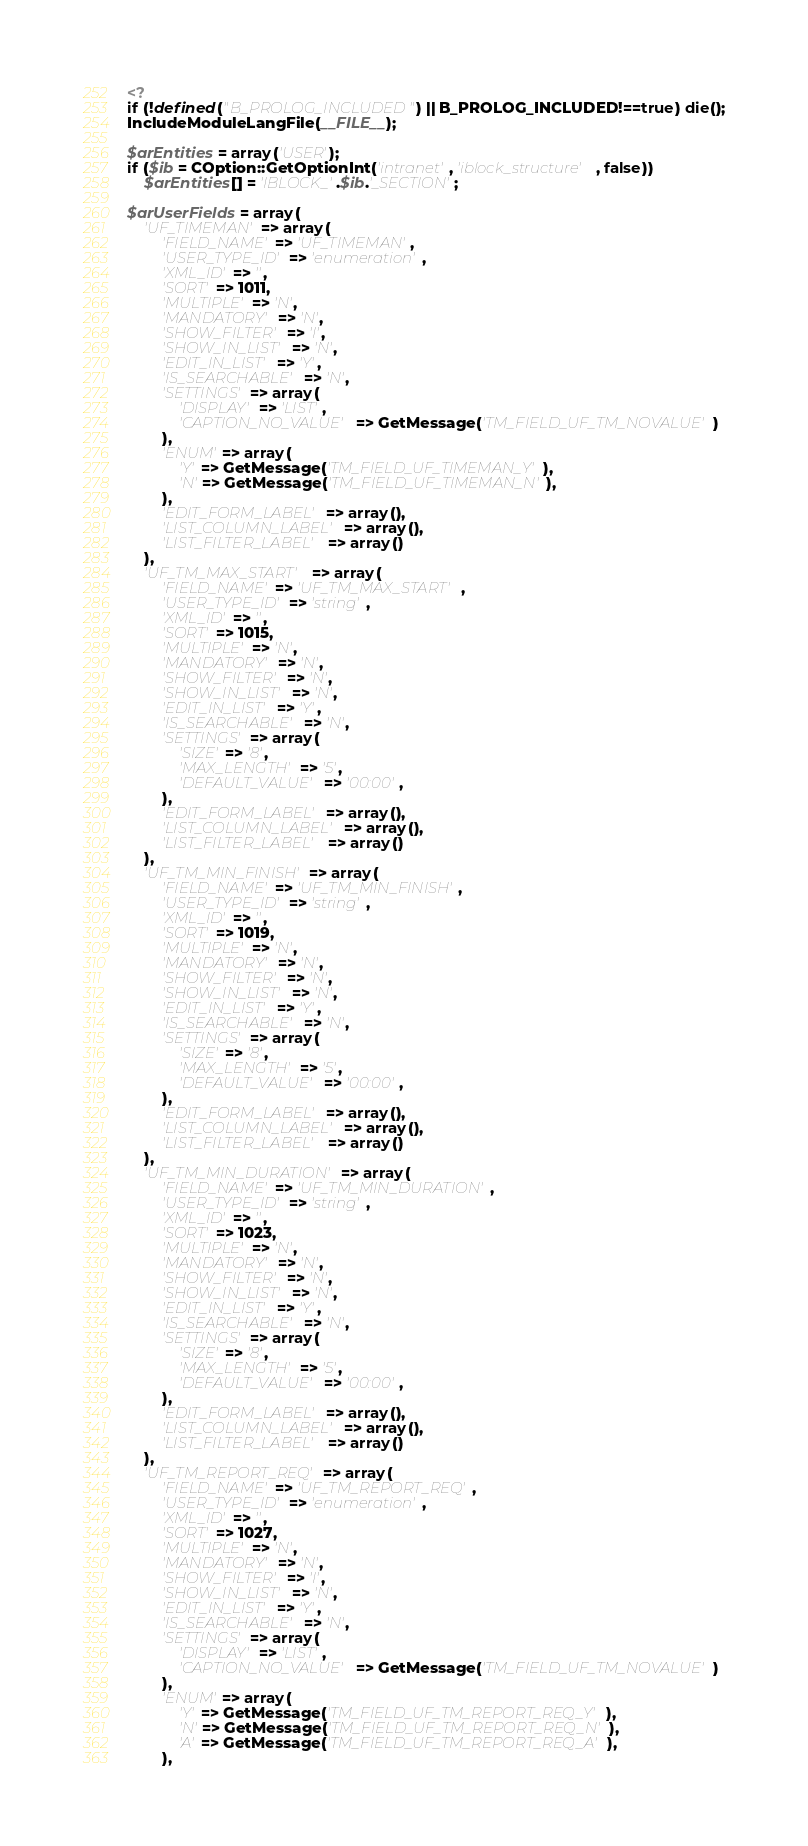Convert code to text. <code><loc_0><loc_0><loc_500><loc_500><_PHP_><?
if (!defined("B_PROLOG_INCLUDED") || B_PROLOG_INCLUDED!==true) die();
IncludeModuleLangFile(__FILE__);

$arEntities = array('USER');
if ($ib = COption::GetOptionInt('intranet', 'iblock_structure', false))
	$arEntities[] = 'IBLOCK_'.$ib.'_SECTION';

$arUserFields = array(
	'UF_TIMEMAN' => array(
		'FIELD_NAME' => 'UF_TIMEMAN',
		'USER_TYPE_ID' => 'enumeration',
		'XML_ID' => '',
		'SORT' => 1011,
		'MULTIPLE' => 'N',
		'MANDATORY' => 'N',
		'SHOW_FILTER' => 'I',
		'SHOW_IN_LIST' => 'N',
		'EDIT_IN_LIST' => 'Y',
		'IS_SEARCHABLE' => 'N',
		'SETTINGS' => array(
			'DISPLAY' => 'LIST',
			'CAPTION_NO_VALUE' => GetMessage('TM_FIELD_UF_TM_NOVALUE')
		),
		'ENUM' => array(
			'Y' => GetMessage('TM_FIELD_UF_TIMEMAN_Y'),
			'N' => GetMessage('TM_FIELD_UF_TIMEMAN_N'),
		),
		'EDIT_FORM_LABEL' => array(),
		'LIST_COLUMN_LABEL' => array(),
		'LIST_FILTER_LABEL' => array()
	),
	'UF_TM_MAX_START' => array(
		'FIELD_NAME' => 'UF_TM_MAX_START',
		'USER_TYPE_ID' => 'string',
		'XML_ID' => '',
		'SORT' => 1015,
		'MULTIPLE' => 'N',
		'MANDATORY' => 'N',
		'SHOW_FILTER' => 'N',
		'SHOW_IN_LIST' => 'N',
		'EDIT_IN_LIST' => 'Y',
		'IS_SEARCHABLE' => 'N',
		'SETTINGS' => array(
			'SIZE' => '8',
			'MAX_LENGTH' => '5',
			'DEFAULT_VALUE' => '00:00',
		),
		'EDIT_FORM_LABEL' => array(),
		'LIST_COLUMN_LABEL' => array(),
		'LIST_FILTER_LABEL' => array()
	),
	'UF_TM_MIN_FINISH' => array(
		'FIELD_NAME' => 'UF_TM_MIN_FINISH',
		'USER_TYPE_ID' => 'string',
		'XML_ID' => '',
		'SORT' => 1019,
		'MULTIPLE' => 'N',
		'MANDATORY' => 'N',
		'SHOW_FILTER' => 'N',
		'SHOW_IN_LIST' => 'N',
		'EDIT_IN_LIST' => 'Y',
		'IS_SEARCHABLE' => 'N',
		'SETTINGS' => array(
			'SIZE' => '8',
			'MAX_LENGTH' => '5',
			'DEFAULT_VALUE' => '00:00',
		),
		'EDIT_FORM_LABEL' => array(),
		'LIST_COLUMN_LABEL' => array(),
		'LIST_FILTER_LABEL' => array()
	),
	'UF_TM_MIN_DURATION' => array(
		'FIELD_NAME' => 'UF_TM_MIN_DURATION',
		'USER_TYPE_ID' => 'string',
		'XML_ID' => '',
		'SORT' => 1023,
		'MULTIPLE' => 'N',
		'MANDATORY' => 'N',
		'SHOW_FILTER' => 'N',
		'SHOW_IN_LIST' => 'N',
		'EDIT_IN_LIST' => 'Y',
		'IS_SEARCHABLE' => 'N',
		'SETTINGS' => array(
			'SIZE' => '8',
			'MAX_LENGTH' => '5',
			'DEFAULT_VALUE' => '00:00',
		),
		'EDIT_FORM_LABEL' => array(),
		'LIST_COLUMN_LABEL' => array(),
		'LIST_FILTER_LABEL' => array()
	),
	'UF_TM_REPORT_REQ' => array(
		'FIELD_NAME' => 'UF_TM_REPORT_REQ',
		'USER_TYPE_ID' => 'enumeration',
		'XML_ID' => '',
		'SORT' => 1027,
		'MULTIPLE' => 'N',
		'MANDATORY' => 'N',
		'SHOW_FILTER' => 'I',
		'SHOW_IN_LIST' => 'N',
		'EDIT_IN_LIST' => 'Y',
		'IS_SEARCHABLE' => 'N',
		'SETTINGS' => array(
			'DISPLAY' => 'LIST',
			'CAPTION_NO_VALUE' => GetMessage('TM_FIELD_UF_TM_NOVALUE')
		),
		'ENUM' => array(
			'Y' => GetMessage('TM_FIELD_UF_TM_REPORT_REQ_Y'),
			'N' => GetMessage('TM_FIELD_UF_TM_REPORT_REQ_N'),
			'A' => GetMessage('TM_FIELD_UF_TM_REPORT_REQ_A'),
		),</code> 